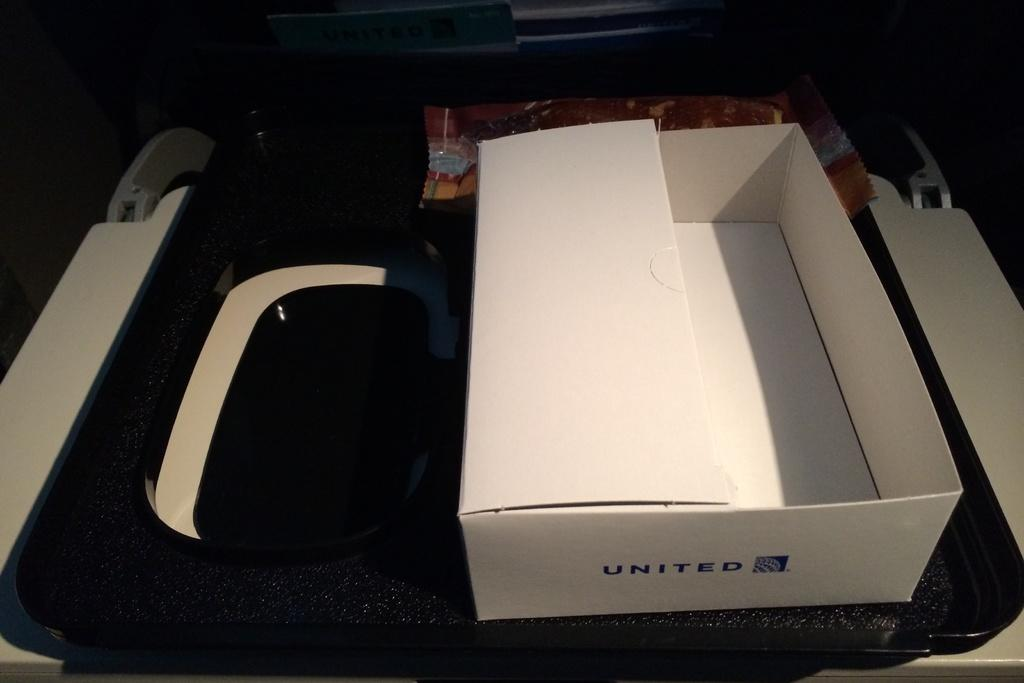Provide a one-sentence caption for the provided image. white box with United printed on it in blue. 